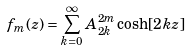Convert formula to latex. <formula><loc_0><loc_0><loc_500><loc_500>f _ { m } ( z ) = \sum _ { k = 0 } ^ { \infty } A _ { 2 k } ^ { 2 m } \cosh [ 2 k z ]</formula> 